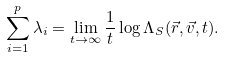<formula> <loc_0><loc_0><loc_500><loc_500>\sum _ { i = 1 } ^ { p } \lambda _ { i } = \lim _ { t \rightarrow \infty } \frac { 1 } { t } \log \Lambda _ { S } ( \vec { r } , \vec { v } , t ) .</formula> 